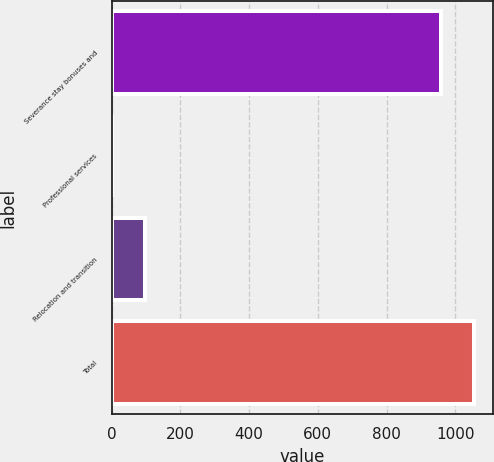Convert chart to OTSL. <chart><loc_0><loc_0><loc_500><loc_500><bar_chart><fcel>Severance stay bonuses and<fcel>Professional services<fcel>Relocation and transition<fcel>Total<nl><fcel>960<fcel>1.85<fcel>97.66<fcel>1055.82<nl></chart> 